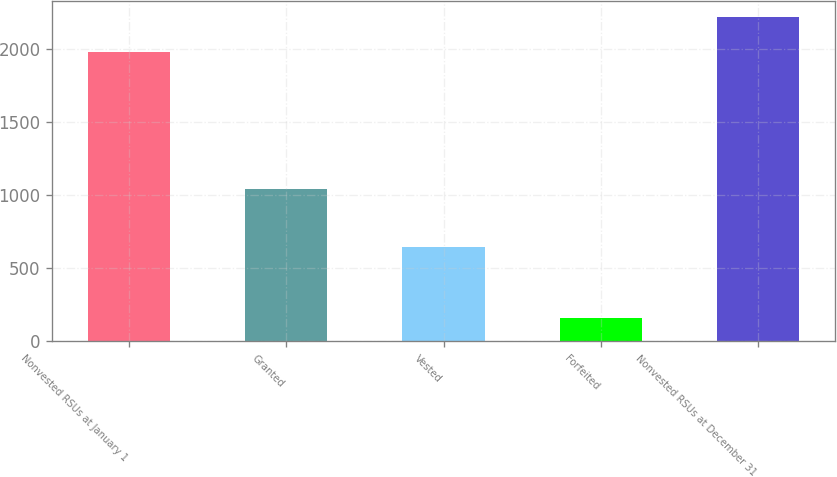Convert chart to OTSL. <chart><loc_0><loc_0><loc_500><loc_500><bar_chart><fcel>Nonvested RSUs at January 1<fcel>Granted<fcel>Vested<fcel>Forfeited<fcel>Nonvested RSUs at December 31<nl><fcel>1979<fcel>1043<fcel>647<fcel>157<fcel>2218<nl></chart> 